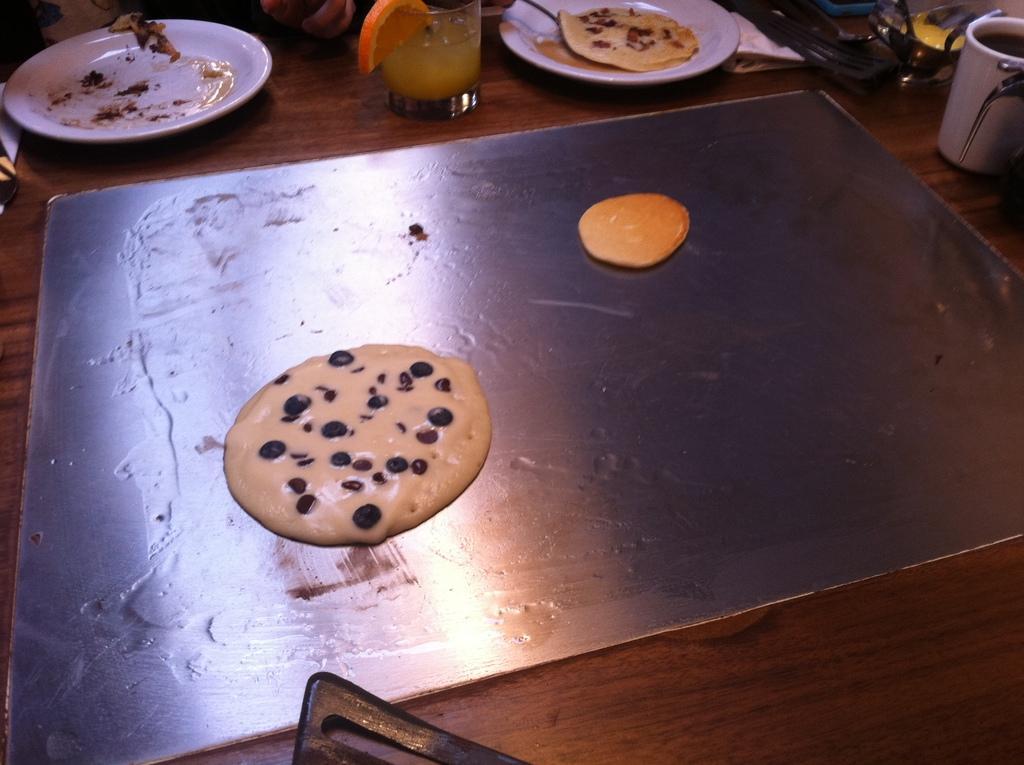Can you describe this image briefly? In this image there is a tray on which there is a cookie dove. In the background there is a plate, Beside the plate there is a glass. On the right side top there is a glass with some juice in it. Beside the glass there is another plate in which there is some food. 